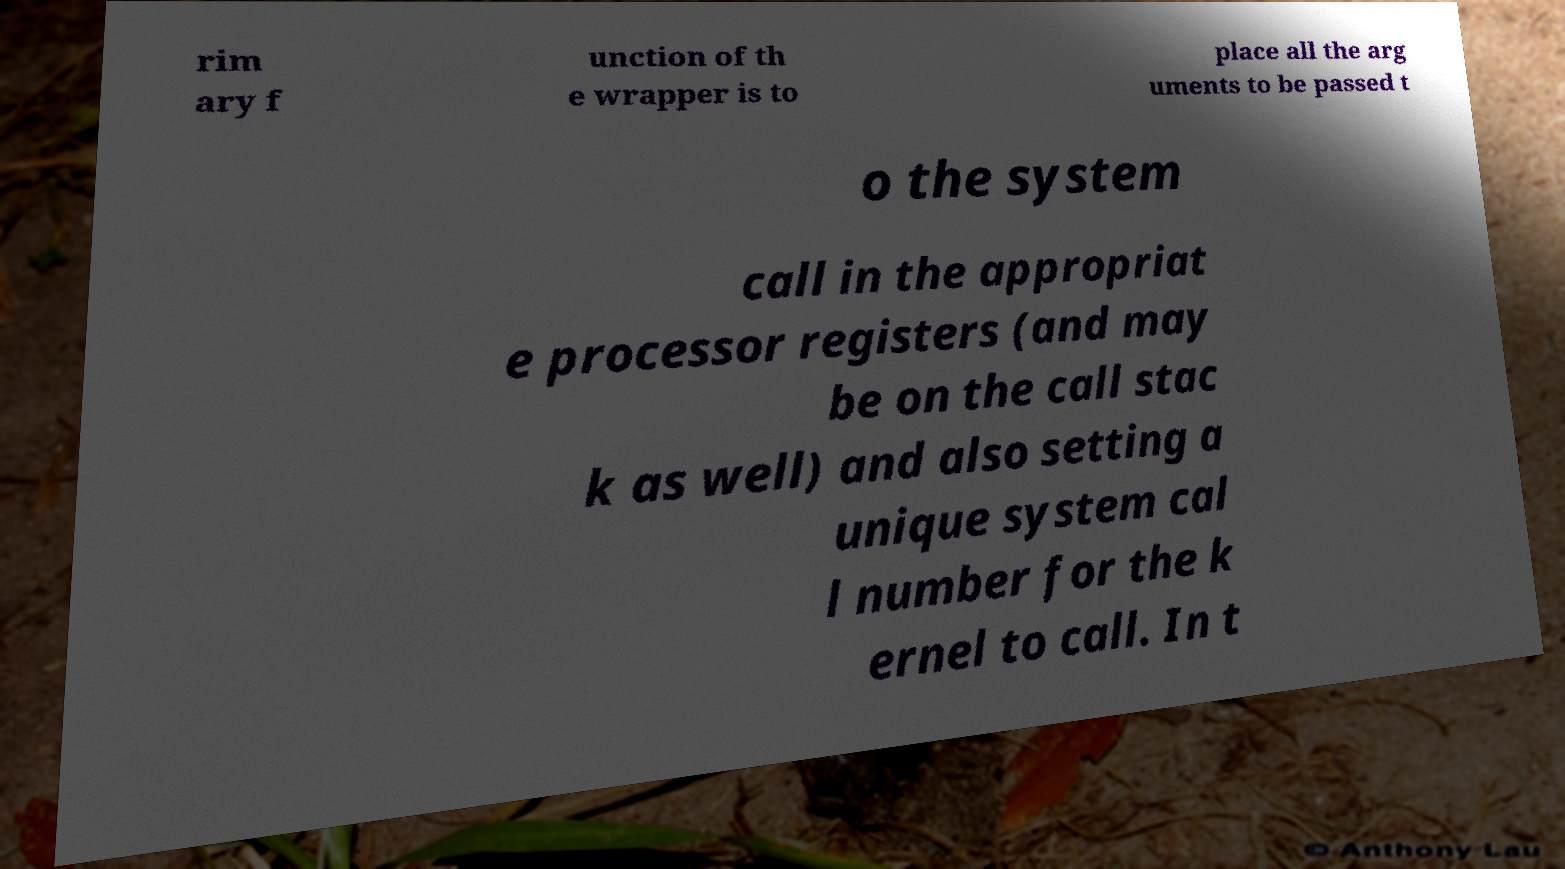There's text embedded in this image that I need extracted. Can you transcribe it verbatim? rim ary f unction of th e wrapper is to place all the arg uments to be passed t o the system call in the appropriat e processor registers (and may be on the call stac k as well) and also setting a unique system cal l number for the k ernel to call. In t 